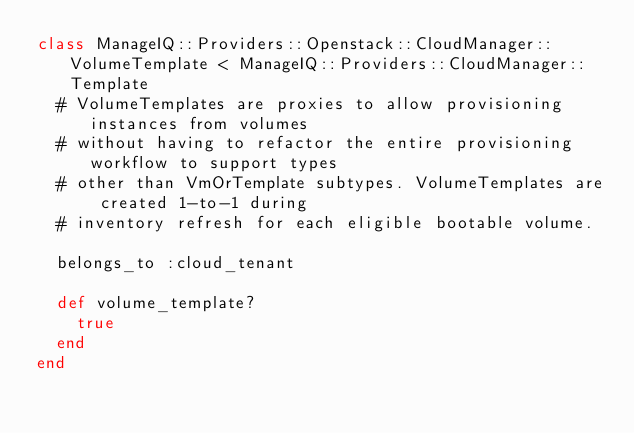Convert code to text. <code><loc_0><loc_0><loc_500><loc_500><_Ruby_>class ManageIQ::Providers::Openstack::CloudManager::VolumeTemplate < ManageIQ::Providers::CloudManager::Template
  # VolumeTemplates are proxies to allow provisioning instances from volumes
  # without having to refactor the entire provisioning workflow to support types
  # other than VmOrTemplate subtypes. VolumeTemplates are created 1-to-1 during
  # inventory refresh for each eligible bootable volume.

  belongs_to :cloud_tenant

  def volume_template?
    true
  end
end
</code> 